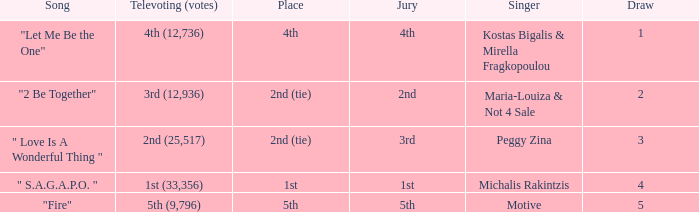The song "2 Be Together" had what jury? 2nd. 